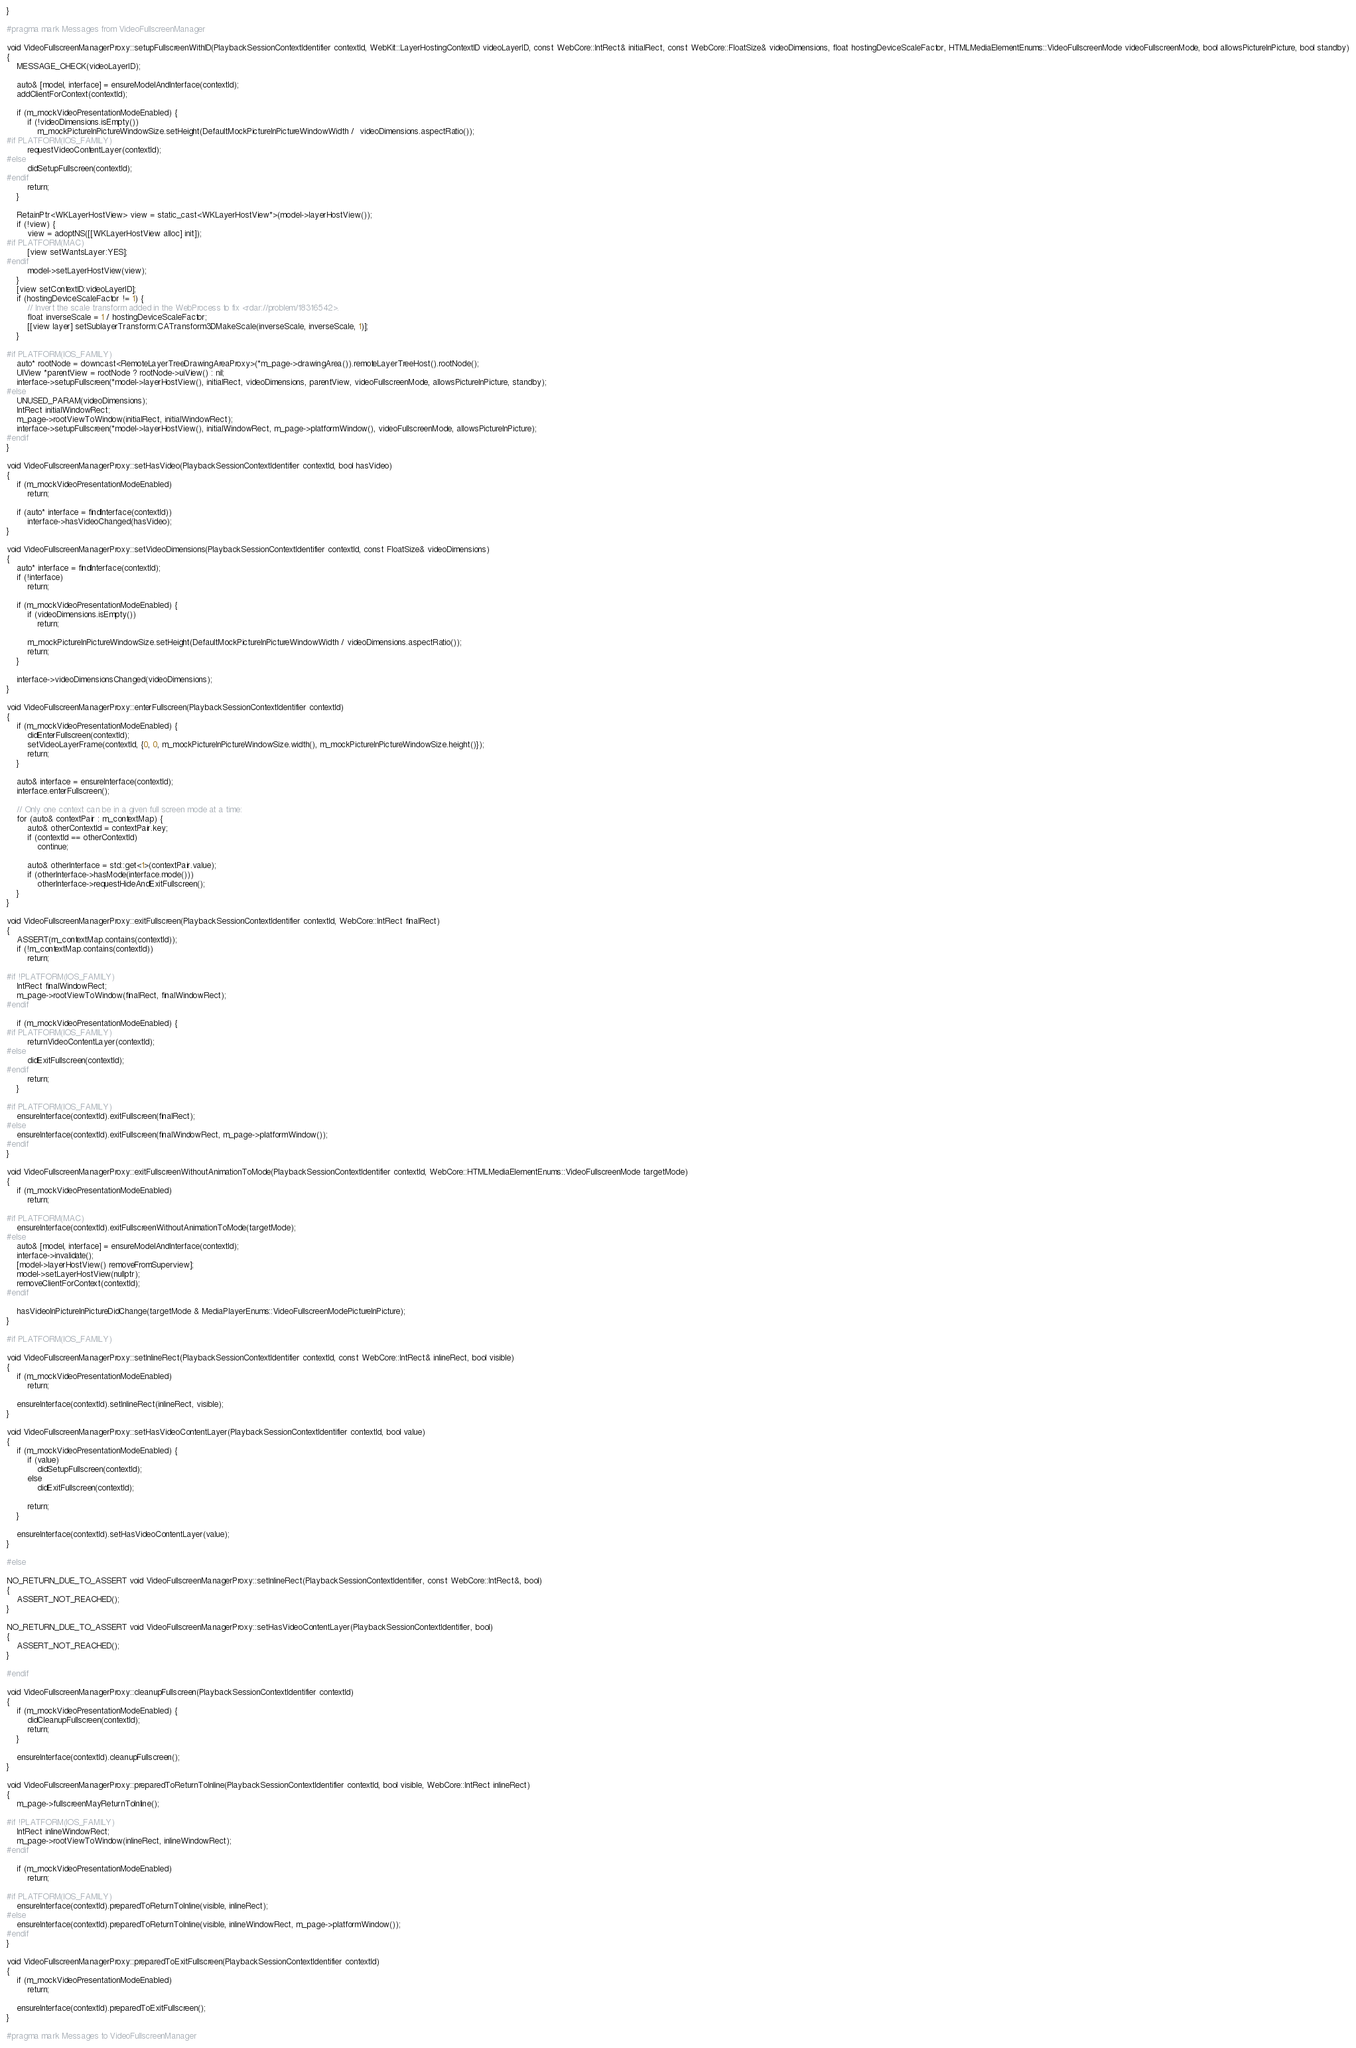<code> <loc_0><loc_0><loc_500><loc_500><_ObjectiveC_>}

#pragma mark Messages from VideoFullscreenManager

void VideoFullscreenManagerProxy::setupFullscreenWithID(PlaybackSessionContextIdentifier contextId, WebKit::LayerHostingContextID videoLayerID, const WebCore::IntRect& initialRect, const WebCore::FloatSize& videoDimensions, float hostingDeviceScaleFactor, HTMLMediaElementEnums::VideoFullscreenMode videoFullscreenMode, bool allowsPictureInPicture, bool standby)
{
    MESSAGE_CHECK(videoLayerID);

    auto& [model, interface] = ensureModelAndInterface(contextId);
    addClientForContext(contextId);

    if (m_mockVideoPresentationModeEnabled) {
        if (!videoDimensions.isEmpty())
            m_mockPictureInPictureWindowSize.setHeight(DefaultMockPictureInPictureWindowWidth /  videoDimensions.aspectRatio());
#if PLATFORM(IOS_FAMILY)
        requestVideoContentLayer(contextId);
#else
        didSetupFullscreen(contextId);
#endif
        return;
    }

    RetainPtr<WKLayerHostView> view = static_cast<WKLayerHostView*>(model->layerHostView());
    if (!view) {
        view = adoptNS([[WKLayerHostView alloc] init]);
#if PLATFORM(MAC)
        [view setWantsLayer:YES];
#endif
        model->setLayerHostView(view);
    }
    [view setContextID:videoLayerID];
    if (hostingDeviceScaleFactor != 1) {
        // Invert the scale transform added in the WebProcess to fix <rdar://problem/18316542>.
        float inverseScale = 1 / hostingDeviceScaleFactor;
        [[view layer] setSublayerTransform:CATransform3DMakeScale(inverseScale, inverseScale, 1)];
    }

#if PLATFORM(IOS_FAMILY)
    auto* rootNode = downcast<RemoteLayerTreeDrawingAreaProxy>(*m_page->drawingArea()).remoteLayerTreeHost().rootNode();
    UIView *parentView = rootNode ? rootNode->uiView() : nil;
    interface->setupFullscreen(*model->layerHostView(), initialRect, videoDimensions, parentView, videoFullscreenMode, allowsPictureInPicture, standby);
#else
    UNUSED_PARAM(videoDimensions);
    IntRect initialWindowRect;
    m_page->rootViewToWindow(initialRect, initialWindowRect);
    interface->setupFullscreen(*model->layerHostView(), initialWindowRect, m_page->platformWindow(), videoFullscreenMode, allowsPictureInPicture);
#endif
}

void VideoFullscreenManagerProxy::setHasVideo(PlaybackSessionContextIdentifier contextId, bool hasVideo)
{
    if (m_mockVideoPresentationModeEnabled)
        return;

    if (auto* interface = findInterface(contextId))
        interface->hasVideoChanged(hasVideo);
}

void VideoFullscreenManagerProxy::setVideoDimensions(PlaybackSessionContextIdentifier contextId, const FloatSize& videoDimensions)
{
    auto* interface = findInterface(contextId);
    if (!interface)
        return;

    if (m_mockVideoPresentationModeEnabled) {
        if (videoDimensions.isEmpty())
            return;

        m_mockPictureInPictureWindowSize.setHeight(DefaultMockPictureInPictureWindowWidth / videoDimensions.aspectRatio());
        return;
    }

    interface->videoDimensionsChanged(videoDimensions);
}

void VideoFullscreenManagerProxy::enterFullscreen(PlaybackSessionContextIdentifier contextId)
{
    if (m_mockVideoPresentationModeEnabled) {
        didEnterFullscreen(contextId);
        setVideoLayerFrame(contextId, {0, 0, m_mockPictureInPictureWindowSize.width(), m_mockPictureInPictureWindowSize.height()});
        return;
    }

    auto& interface = ensureInterface(contextId);
    interface.enterFullscreen();

    // Only one context can be in a given full screen mode at a time:
    for (auto& contextPair : m_contextMap) {
        auto& otherContextId = contextPair.key;
        if (contextId == otherContextId)
            continue;

        auto& otherInterface = std::get<1>(contextPair.value);
        if (otherInterface->hasMode(interface.mode()))
            otherInterface->requestHideAndExitFullscreen();
    }
}

void VideoFullscreenManagerProxy::exitFullscreen(PlaybackSessionContextIdentifier contextId, WebCore::IntRect finalRect)
{
    ASSERT(m_contextMap.contains(contextId));
    if (!m_contextMap.contains(contextId))
        return;

#if !PLATFORM(IOS_FAMILY)
    IntRect finalWindowRect;
    m_page->rootViewToWindow(finalRect, finalWindowRect);
#endif

    if (m_mockVideoPresentationModeEnabled) {
#if PLATFORM(IOS_FAMILY)
        returnVideoContentLayer(contextId);
#else
        didExitFullscreen(contextId);
#endif
        return;
    }

#if PLATFORM(IOS_FAMILY)
    ensureInterface(contextId).exitFullscreen(finalRect);
#else
    ensureInterface(contextId).exitFullscreen(finalWindowRect, m_page->platformWindow());
#endif
}

void VideoFullscreenManagerProxy::exitFullscreenWithoutAnimationToMode(PlaybackSessionContextIdentifier contextId, WebCore::HTMLMediaElementEnums::VideoFullscreenMode targetMode)
{
    if (m_mockVideoPresentationModeEnabled)
        return;

#if PLATFORM(MAC)
    ensureInterface(contextId).exitFullscreenWithoutAnimationToMode(targetMode);
#else
    auto& [model, interface] = ensureModelAndInterface(contextId);
    interface->invalidate();
    [model->layerHostView() removeFromSuperview];
    model->setLayerHostView(nullptr);
    removeClientForContext(contextId);
#endif

    hasVideoInPictureInPictureDidChange(targetMode & MediaPlayerEnums::VideoFullscreenModePictureInPicture);
}

#if PLATFORM(IOS_FAMILY)

void VideoFullscreenManagerProxy::setInlineRect(PlaybackSessionContextIdentifier contextId, const WebCore::IntRect& inlineRect, bool visible)
{
    if (m_mockVideoPresentationModeEnabled)
        return;

    ensureInterface(contextId).setInlineRect(inlineRect, visible);
}

void VideoFullscreenManagerProxy::setHasVideoContentLayer(PlaybackSessionContextIdentifier contextId, bool value)
{
    if (m_mockVideoPresentationModeEnabled) {
        if (value)
            didSetupFullscreen(contextId);
        else
            didExitFullscreen(contextId);

        return;
    }

    ensureInterface(contextId).setHasVideoContentLayer(value);
}

#else

NO_RETURN_DUE_TO_ASSERT void VideoFullscreenManagerProxy::setInlineRect(PlaybackSessionContextIdentifier, const WebCore::IntRect&, bool)
{
    ASSERT_NOT_REACHED();
}

NO_RETURN_DUE_TO_ASSERT void VideoFullscreenManagerProxy::setHasVideoContentLayer(PlaybackSessionContextIdentifier, bool)
{
    ASSERT_NOT_REACHED();
}

#endif

void VideoFullscreenManagerProxy::cleanupFullscreen(PlaybackSessionContextIdentifier contextId)
{
    if (m_mockVideoPresentationModeEnabled) {
        didCleanupFullscreen(contextId);
        return;
    }

    ensureInterface(contextId).cleanupFullscreen();
}

void VideoFullscreenManagerProxy::preparedToReturnToInline(PlaybackSessionContextIdentifier contextId, bool visible, WebCore::IntRect inlineRect)
{
    m_page->fullscreenMayReturnToInline();

#if !PLATFORM(IOS_FAMILY)
    IntRect inlineWindowRect;
    m_page->rootViewToWindow(inlineRect, inlineWindowRect);
#endif

    if (m_mockVideoPresentationModeEnabled)
        return;

#if PLATFORM(IOS_FAMILY)
    ensureInterface(contextId).preparedToReturnToInline(visible, inlineRect);
#else
    ensureInterface(contextId).preparedToReturnToInline(visible, inlineWindowRect, m_page->platformWindow());
#endif
}

void VideoFullscreenManagerProxy::preparedToExitFullscreen(PlaybackSessionContextIdentifier contextId)
{
    if (m_mockVideoPresentationModeEnabled)
        return;

    ensureInterface(contextId).preparedToExitFullscreen();
}

#pragma mark Messages to VideoFullscreenManager
</code> 